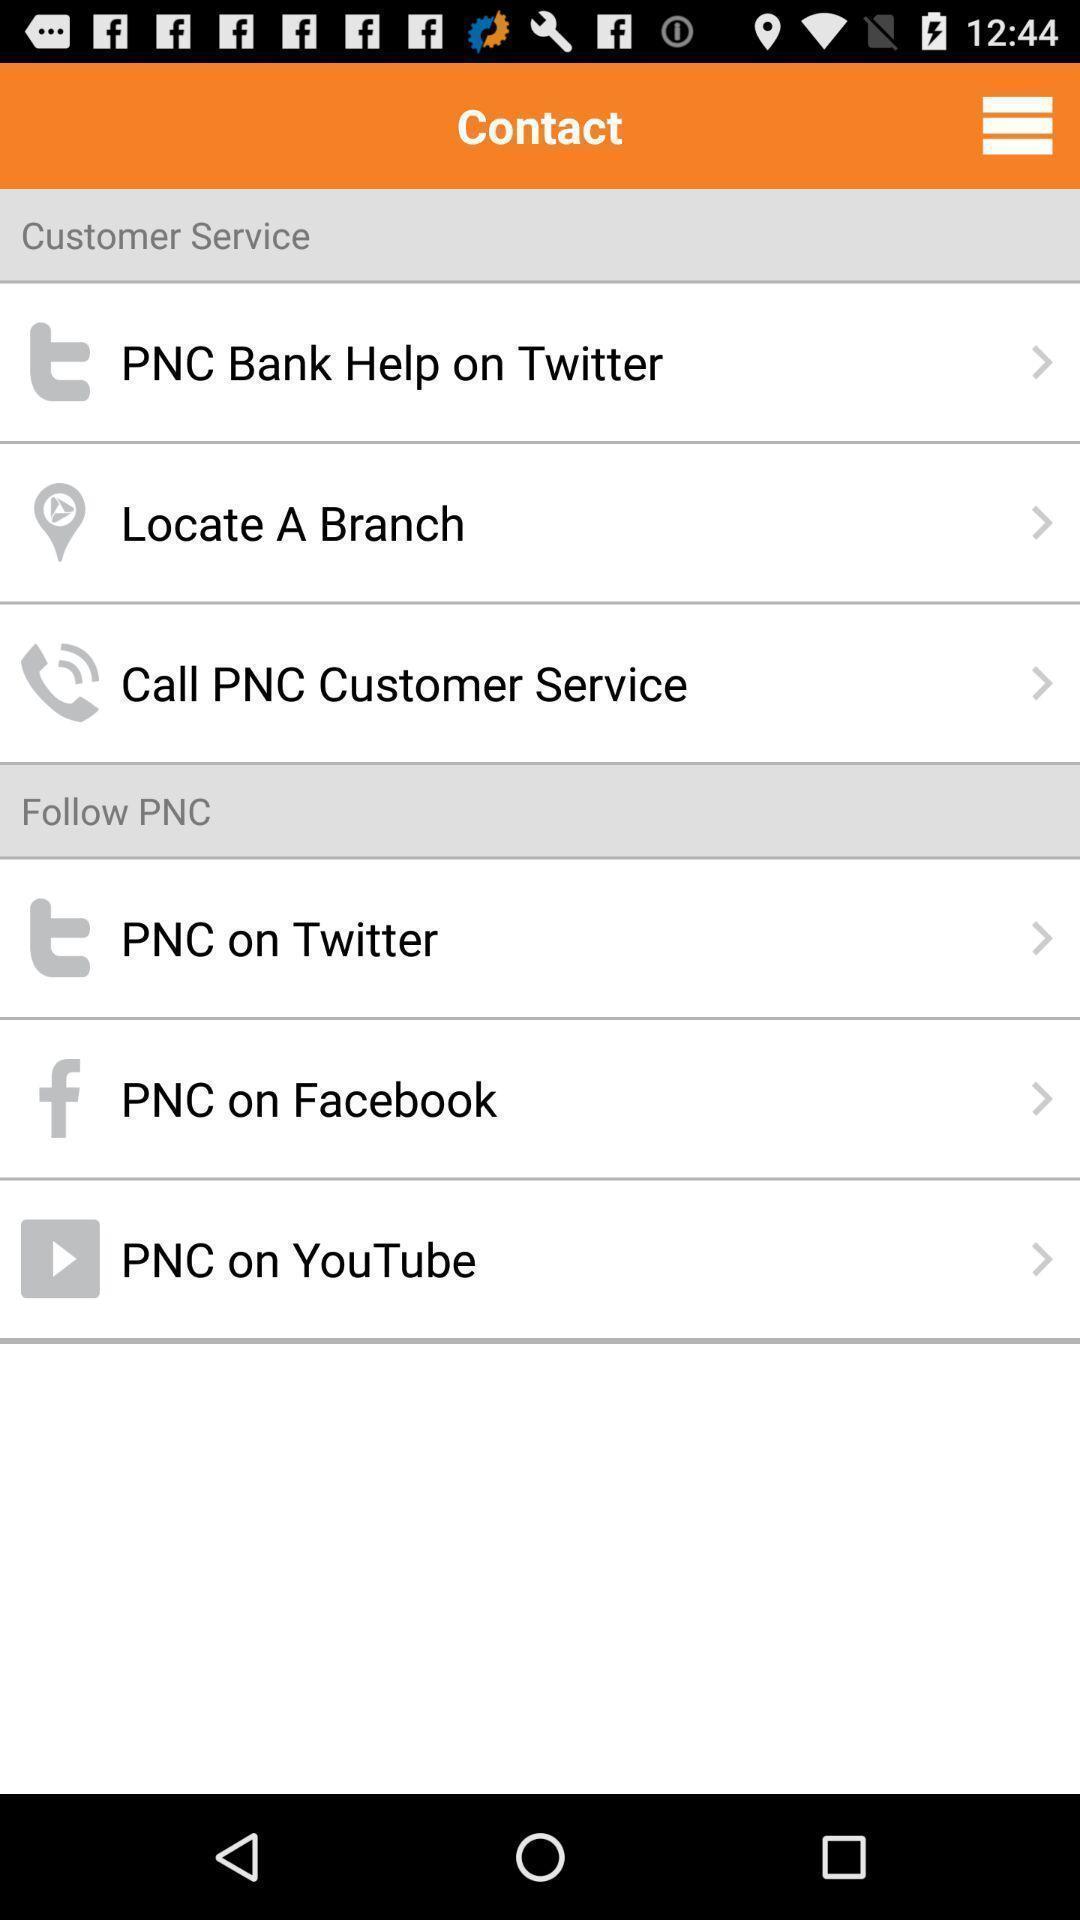Describe the content in this image. Screen displaying contact page. 